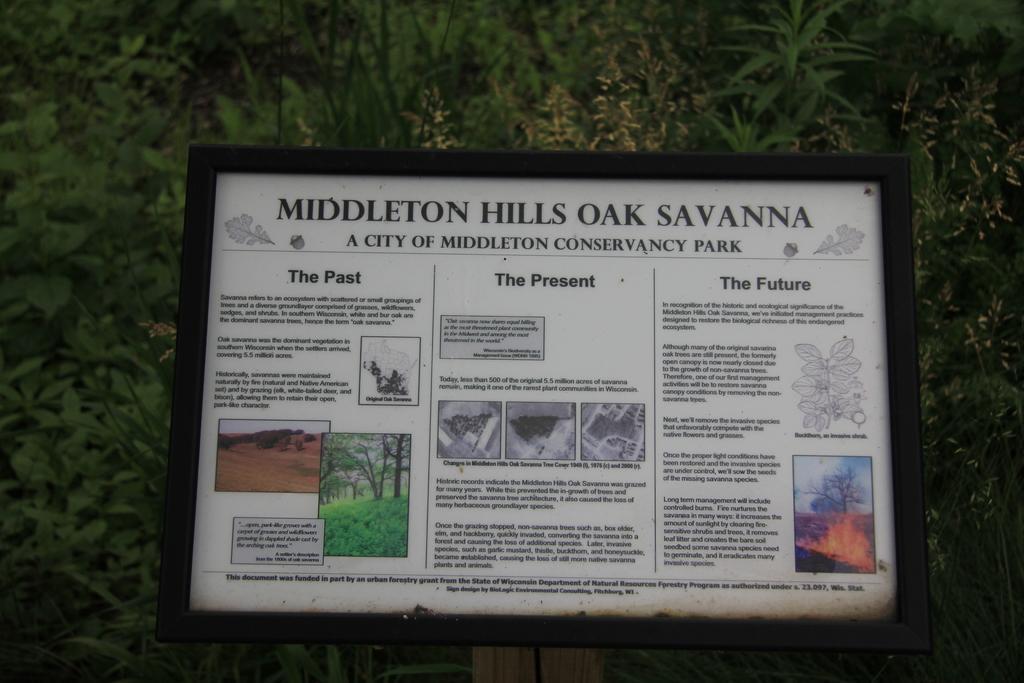How would you summarize this image in a sentence or two? In the middle of this image, there is a poster having images and black color texts. This poster is in a frame and is attached to a pole. In the background, there are trees. 